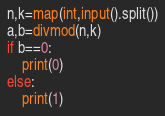<code> <loc_0><loc_0><loc_500><loc_500><_Python_>n,k=map(int,input().split())
a,b=divmod(n,k)
if b==0:
    print(0)
else:
    print(1)</code> 